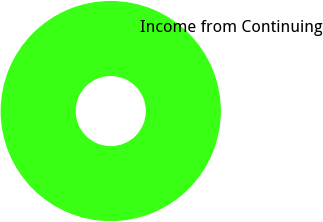<chart> <loc_0><loc_0><loc_500><loc_500><pie_chart><fcel>Income from Continuing<nl><fcel>100.0%<nl></chart> 